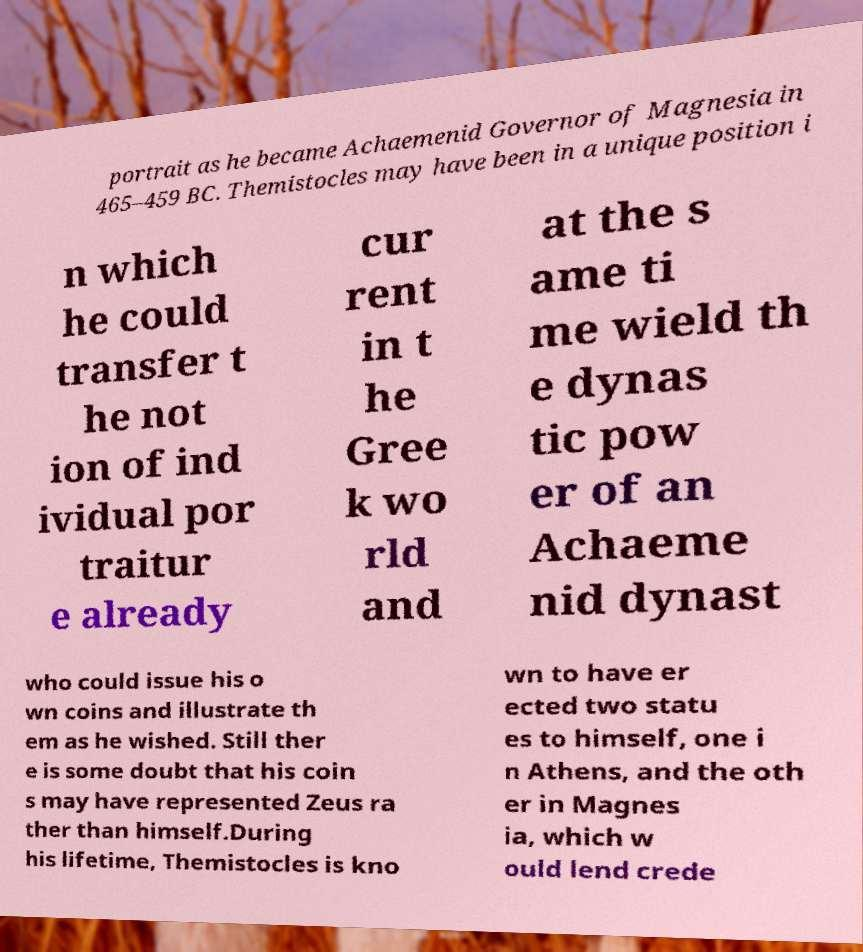There's text embedded in this image that I need extracted. Can you transcribe it verbatim? portrait as he became Achaemenid Governor of Magnesia in 465–459 BC. Themistocles may have been in a unique position i n which he could transfer t he not ion of ind ividual por traitur e already cur rent in t he Gree k wo rld and at the s ame ti me wield th e dynas tic pow er of an Achaeme nid dynast who could issue his o wn coins and illustrate th em as he wished. Still ther e is some doubt that his coin s may have represented Zeus ra ther than himself.During his lifetime, Themistocles is kno wn to have er ected two statu es to himself, one i n Athens, and the oth er in Magnes ia, which w ould lend crede 